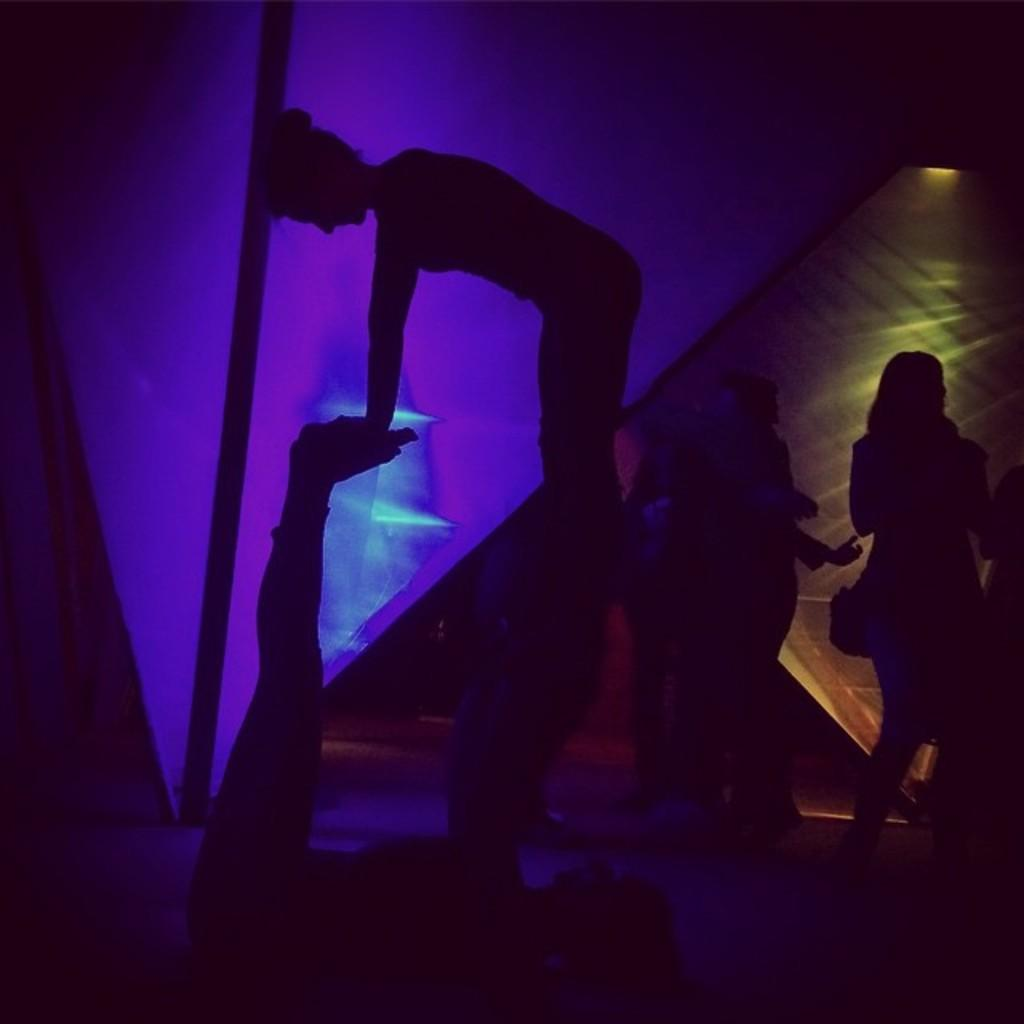How many people are in the image? There is a group of people in the image. Can you describe the pose of two people in the image? Two people are in a pose in the image. What type of objects with lights can be seen in the background? There are objects with lights in the background. What is present in the background that is not related to lights? There is a pole in the background. What type of lizards can be seen climbing the pole in the image? There are no lizards present in the image, and therefore no such activity can be observed. 